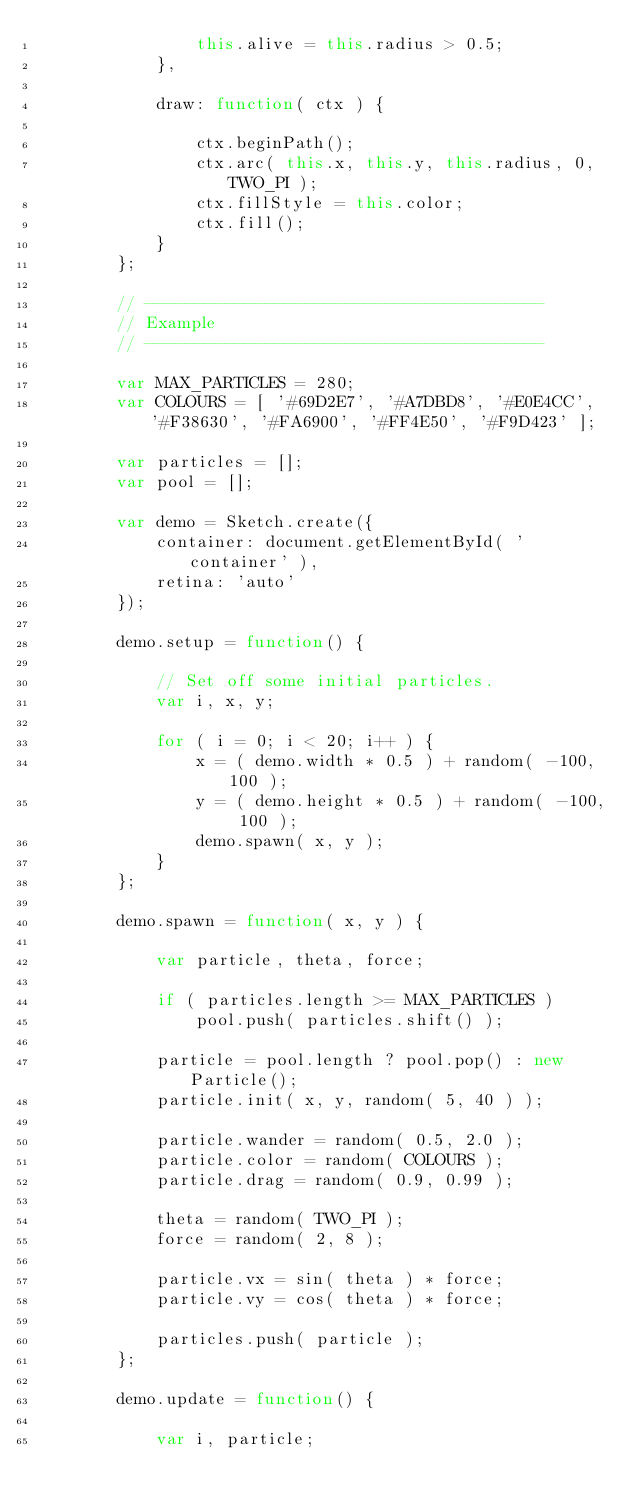<code> <loc_0><loc_0><loc_500><loc_500><_JavaScript_>                this.alive = this.radius > 0.5;
            },

            draw: function( ctx ) {

                ctx.beginPath();
                ctx.arc( this.x, this.y, this.radius, 0, TWO_PI );
                ctx.fillStyle = this.color;
                ctx.fill();
            }
        };

        // ----------------------------------------
        // Example
        // ----------------------------------------

        var MAX_PARTICLES = 280;
        var COLOURS = [ '#69D2E7', '#A7DBD8', '#E0E4CC', '#F38630', '#FA6900', '#FF4E50', '#F9D423' ];

        var particles = [];
        var pool = [];

        var demo = Sketch.create({
            container: document.getElementById( 'container' ),
            retina: 'auto'
        });

        demo.setup = function() {

            // Set off some initial particles.
            var i, x, y;

            for ( i = 0; i < 20; i++ ) {
                x = ( demo.width * 0.5 ) + random( -100, 100 );
                y = ( demo.height * 0.5 ) + random( -100, 100 );
                demo.spawn( x, y );
            }
        };

        demo.spawn = function( x, y ) {
            
            var particle, theta, force;

            if ( particles.length >= MAX_PARTICLES )
                pool.push( particles.shift() );

            particle = pool.length ? pool.pop() : new Particle();
            particle.init( x, y, random( 5, 40 ) );

            particle.wander = random( 0.5, 2.0 );
            particle.color = random( COLOURS );
            particle.drag = random( 0.9, 0.99 );

            theta = random( TWO_PI );
            force = random( 2, 8 );

            particle.vx = sin( theta ) * force;
            particle.vy = cos( theta ) * force;

            particles.push( particle );
        };

        demo.update = function() {

            var i, particle;
</code> 